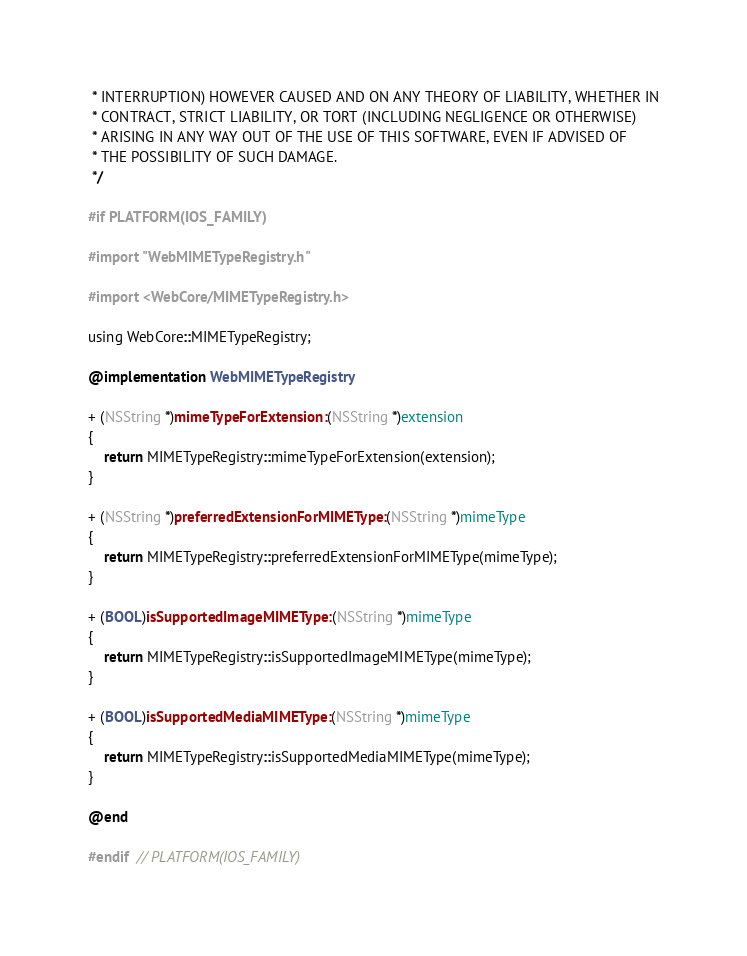<code> <loc_0><loc_0><loc_500><loc_500><_ObjectiveC_> * INTERRUPTION) HOWEVER CAUSED AND ON ANY THEORY OF LIABILITY, WHETHER IN
 * CONTRACT, STRICT LIABILITY, OR TORT (INCLUDING NEGLIGENCE OR OTHERWISE)
 * ARISING IN ANY WAY OUT OF THE USE OF THIS SOFTWARE, EVEN IF ADVISED OF
 * THE POSSIBILITY OF SUCH DAMAGE.
 */

#if PLATFORM(IOS_FAMILY)

#import "WebMIMETypeRegistry.h"

#import <WebCore/MIMETypeRegistry.h>

using WebCore::MIMETypeRegistry;

@implementation WebMIMETypeRegistry

+ (NSString *)mimeTypeForExtension:(NSString *)extension
{
    return MIMETypeRegistry::mimeTypeForExtension(extension);
}

+ (NSString *)preferredExtensionForMIMEType:(NSString *)mimeType
{
    return MIMETypeRegistry::preferredExtensionForMIMEType(mimeType);
}

+ (BOOL)isSupportedImageMIMEType:(NSString *)mimeType
{
    return MIMETypeRegistry::isSupportedImageMIMEType(mimeType);
}

+ (BOOL)isSupportedMediaMIMEType:(NSString *)mimeType
{
    return MIMETypeRegistry::isSupportedMediaMIMEType(mimeType);
}

@end

#endif  // PLATFORM(IOS_FAMILY)
</code> 